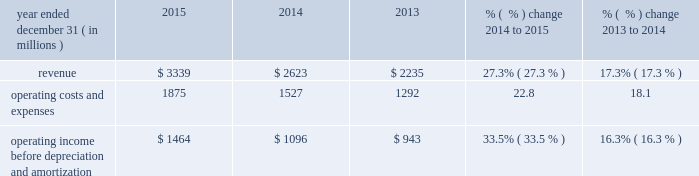Other operating and administrative expenses increased slightly in 2015 due to increased expenses asso- ciated with our larger film slate .
Other operating and administrative expenses increased in 2014 primarily due to the inclusion of fandango , which was previously presented in our cable networks segment .
Advertising , marketing and promotion expenses advertising , marketing and promotion expenses consist primarily of expenses associated with advertising for our theatrical releases and the marketing of our films on dvd and in digital formats .
We incur significant marketing expenses before and throughout the release of a film in movie theaters .
As a result , we typically incur losses on a film prior to and during the film 2019s exhibition in movie theaters and may not realize profits , if any , until the film generates home entertainment and content licensing revenue .
The costs associated with producing and marketing films have generally increased in recent years and may continue to increase in the future .
Advertising , marketing and promotion expenses increased in 2015 primarily due to higher promotional costs associated with our larger 2015 film slate and increased advertising expenses for fandango .
Advertising , marketing and promotion expenses decreased in 2014 primarily due to fewer major film releases compared to theme parks segment results of operations year ended december 31 ( in millions ) 2015 2014 2013 % (  % ) change 2014 to 2015 % (  % ) change 2013 to 2014 .
Operating income before depreciation and amortization $ 1464 $ 1096 $ 943 33.5% ( 33.5 % ) 16.3% ( 16.3 % ) theme parks segment 2013 revenue in 2015 , our theme parks segment revenue was generated primarily from ticket sales and guest spending at our universal theme parks in orlando , florida and hollywood , california , as well as from licensing and other fees .
In november 2015 , nbcuniversal acquired a 51% ( 51 % ) interest in universal studios japan .
Guest spending includes in-park spending on food , beverages and merchandise .
Guest attendance at our theme parks and guest spending depend heavily on the general environment for travel and tourism , including consumer spend- ing on travel and other recreational activities .
Licensing and other fees relate primarily to our agreements with third parties that own and operate the universal studios singapore theme park , as well as from the universal studios japan theme park , to license the right to use the universal studios brand name and other intellectual property .
Theme parks segment revenue increased in 2015 and 2014 primarily due to increases in guest attendance and increases in guest spending at our orlando and hollywood theme parks .
The increase in 2015 was pri- marily due to the continued success of our attractions , including the wizarding world of harry potter 2122 2014 diagon alley 2122 in orlando and the fast & furious 2122 2014 supercharged 2122 studio tour and the simpson 2019s springfield attraction in hollywood , both of which opened in 2015 .
In addition , theme parks segment revenue in 2015 includes $ 169 million of revenue attributable to universal studios japan for the period from november 13 , 2015 to december 31 , 2015 .
The increase in 2014 was primarily due to new attractions , such as the wizarding world of harry potter 2122 2014 diagon alley 2122 in orlando , which opened in july 2014 , and despicable me : minion mayhem in hollywood .
59 comcast 2015 annual report on form 10-k .
What was the operating profit margin for the year of 2014? 
Computations: (1096 / 2623)
Answer: 0.41784. Other operating and administrative expenses increased slightly in 2015 due to increased expenses asso- ciated with our larger film slate .
Other operating and administrative expenses increased in 2014 primarily due to the inclusion of fandango , which was previously presented in our cable networks segment .
Advertising , marketing and promotion expenses advertising , marketing and promotion expenses consist primarily of expenses associated with advertising for our theatrical releases and the marketing of our films on dvd and in digital formats .
We incur significant marketing expenses before and throughout the release of a film in movie theaters .
As a result , we typically incur losses on a film prior to and during the film 2019s exhibition in movie theaters and may not realize profits , if any , until the film generates home entertainment and content licensing revenue .
The costs associated with producing and marketing films have generally increased in recent years and may continue to increase in the future .
Advertising , marketing and promotion expenses increased in 2015 primarily due to higher promotional costs associated with our larger 2015 film slate and increased advertising expenses for fandango .
Advertising , marketing and promotion expenses decreased in 2014 primarily due to fewer major film releases compared to theme parks segment results of operations year ended december 31 ( in millions ) 2015 2014 2013 % (  % ) change 2014 to 2015 % (  % ) change 2013 to 2014 .
Operating income before depreciation and amortization $ 1464 $ 1096 $ 943 33.5% ( 33.5 % ) 16.3% ( 16.3 % ) theme parks segment 2013 revenue in 2015 , our theme parks segment revenue was generated primarily from ticket sales and guest spending at our universal theme parks in orlando , florida and hollywood , california , as well as from licensing and other fees .
In november 2015 , nbcuniversal acquired a 51% ( 51 % ) interest in universal studios japan .
Guest spending includes in-park spending on food , beverages and merchandise .
Guest attendance at our theme parks and guest spending depend heavily on the general environment for travel and tourism , including consumer spend- ing on travel and other recreational activities .
Licensing and other fees relate primarily to our agreements with third parties that own and operate the universal studios singapore theme park , as well as from the universal studios japan theme park , to license the right to use the universal studios brand name and other intellectual property .
Theme parks segment revenue increased in 2015 and 2014 primarily due to increases in guest attendance and increases in guest spending at our orlando and hollywood theme parks .
The increase in 2015 was pri- marily due to the continued success of our attractions , including the wizarding world of harry potter 2122 2014 diagon alley 2122 in orlando and the fast & furious 2122 2014 supercharged 2122 studio tour and the simpson 2019s springfield attraction in hollywood , both of which opened in 2015 .
In addition , theme parks segment revenue in 2015 includes $ 169 million of revenue attributable to universal studios japan for the period from november 13 , 2015 to december 31 , 2015 .
The increase in 2014 was primarily due to new attractions , such as the wizarding world of harry potter 2122 2014 diagon alley 2122 in orlando , which opened in july 2014 , and despicable me : minion mayhem in hollywood .
59 comcast 2015 annual report on form 10-k .
What was the average operating income before depreciation and amortization from 2013 to 2015? 
Computations: (((943 + (1464 + 1096)) + 3) / 2)
Answer: 1753.0. Other operating and administrative expenses increased slightly in 2015 due to increased expenses asso- ciated with our larger film slate .
Other operating and administrative expenses increased in 2014 primarily due to the inclusion of fandango , which was previously presented in our cable networks segment .
Advertising , marketing and promotion expenses advertising , marketing and promotion expenses consist primarily of expenses associated with advertising for our theatrical releases and the marketing of our films on dvd and in digital formats .
We incur significant marketing expenses before and throughout the release of a film in movie theaters .
As a result , we typically incur losses on a film prior to and during the film 2019s exhibition in movie theaters and may not realize profits , if any , until the film generates home entertainment and content licensing revenue .
The costs associated with producing and marketing films have generally increased in recent years and may continue to increase in the future .
Advertising , marketing and promotion expenses increased in 2015 primarily due to higher promotional costs associated with our larger 2015 film slate and increased advertising expenses for fandango .
Advertising , marketing and promotion expenses decreased in 2014 primarily due to fewer major film releases compared to theme parks segment results of operations year ended december 31 ( in millions ) 2015 2014 2013 % (  % ) change 2014 to 2015 % (  % ) change 2013 to 2014 .
Operating income before depreciation and amortization $ 1464 $ 1096 $ 943 33.5% ( 33.5 % ) 16.3% ( 16.3 % ) theme parks segment 2013 revenue in 2015 , our theme parks segment revenue was generated primarily from ticket sales and guest spending at our universal theme parks in orlando , florida and hollywood , california , as well as from licensing and other fees .
In november 2015 , nbcuniversal acquired a 51% ( 51 % ) interest in universal studios japan .
Guest spending includes in-park spending on food , beverages and merchandise .
Guest attendance at our theme parks and guest spending depend heavily on the general environment for travel and tourism , including consumer spend- ing on travel and other recreational activities .
Licensing and other fees relate primarily to our agreements with third parties that own and operate the universal studios singapore theme park , as well as from the universal studios japan theme park , to license the right to use the universal studios brand name and other intellectual property .
Theme parks segment revenue increased in 2015 and 2014 primarily due to increases in guest attendance and increases in guest spending at our orlando and hollywood theme parks .
The increase in 2015 was pri- marily due to the continued success of our attractions , including the wizarding world of harry potter 2122 2014 diagon alley 2122 in orlando and the fast & furious 2122 2014 supercharged 2122 studio tour and the simpson 2019s springfield attraction in hollywood , both of which opened in 2015 .
In addition , theme parks segment revenue in 2015 includes $ 169 million of revenue attributable to universal studios japan for the period from november 13 , 2015 to december 31 , 2015 .
The increase in 2014 was primarily due to new attractions , such as the wizarding world of harry potter 2122 2014 diagon alley 2122 in orlando , which opened in july 2014 , and despicable me : minion mayhem in hollywood .
59 comcast 2015 annual report on form 10-k .
In 2015 what was the profit margin before before depreciation and amortization? 
Computations: (1464 / 3339)
Answer: 0.43845. 